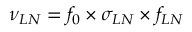Convert formula to latex. <formula><loc_0><loc_0><loc_500><loc_500>\nu _ { L N } = f _ { 0 } \times \sigma _ { L N } \times f _ { L N }</formula> 